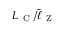Convert formula to latex. <formula><loc_0><loc_0><loc_500><loc_500>L _ { C } / \bar { \ell } _ { Z }</formula> 